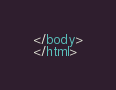<code> <loc_0><loc_0><loc_500><loc_500><_HTML_></body>
</html>
</code> 